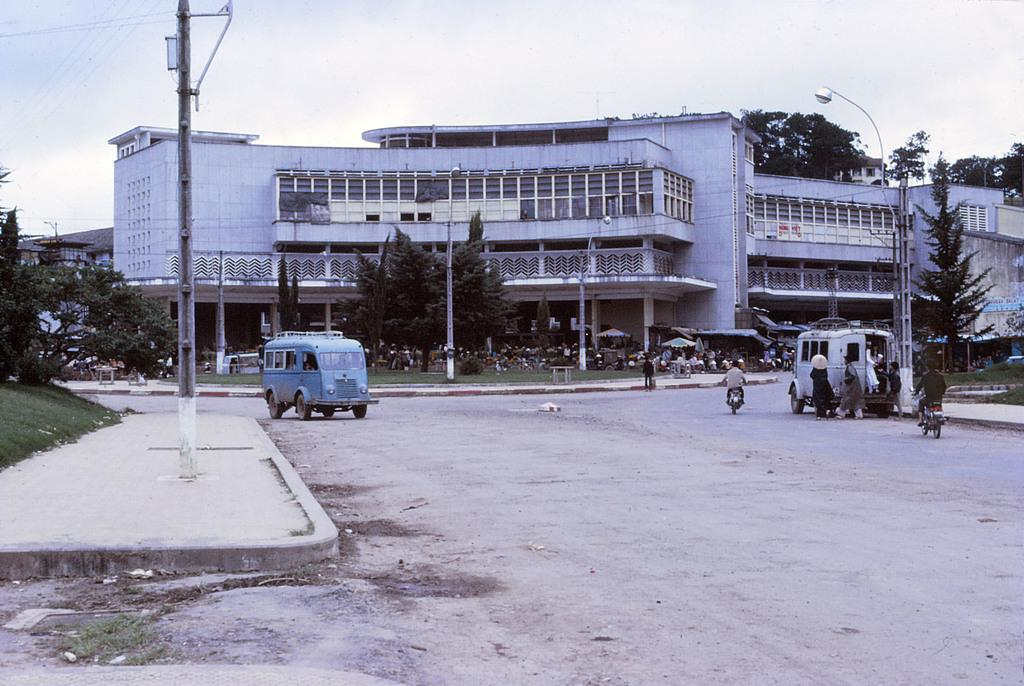What type of structures can be seen in the image? There are buildings in the image. What natural elements are present in the image? There are trees and grass in the image. What man-made objects can be seen in the image? There are vehicles, electric poles, lights, and umbrellas in the image. Are there any living beings in the image? Yes, there are people in the image. What is visible in the background of the image? The sky is visible in the background of the image. Where is the heart-shaped cushion located in the image? There is no heart-shaped cushion present in the image. What type of quilt is draped over the people in the image? There is no quilt present in the image; the people are not covered by any fabric. 